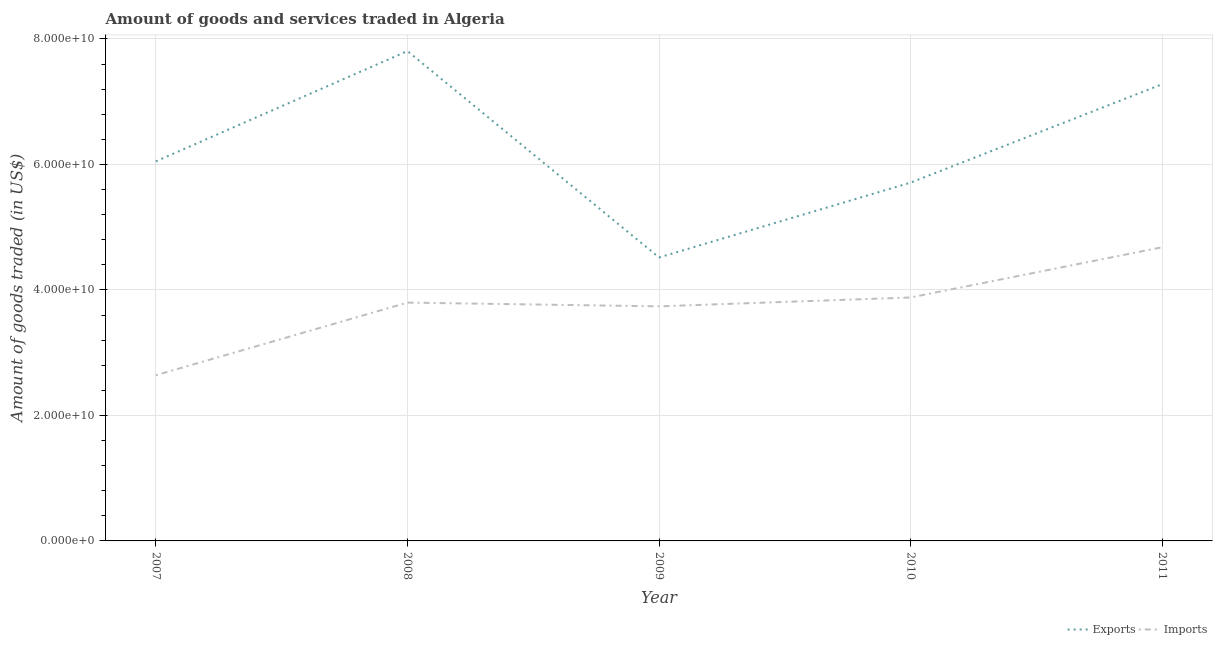What is the amount of goods exported in 2010?
Ensure brevity in your answer.  5.71e+1. Across all years, what is the maximum amount of goods exported?
Ensure brevity in your answer.  7.81e+1. Across all years, what is the minimum amount of goods exported?
Ensure brevity in your answer.  4.52e+1. In which year was the amount of goods exported minimum?
Your response must be concise. 2009. What is the total amount of goods exported in the graph?
Your answer should be very brief. 3.14e+11. What is the difference between the amount of goods imported in 2008 and that in 2011?
Make the answer very short. -8.82e+09. What is the difference between the amount of goods imported in 2008 and the amount of goods exported in 2009?
Provide a succinct answer. -7.19e+09. What is the average amount of goods imported per year?
Your response must be concise. 3.75e+1. In the year 2009, what is the difference between the amount of goods imported and amount of goods exported?
Provide a succinct answer. -7.79e+09. What is the ratio of the amount of goods imported in 2007 to that in 2011?
Give a very brief answer. 0.56. What is the difference between the highest and the second highest amount of goods imported?
Your answer should be compact. 8.00e+09. What is the difference between the highest and the lowest amount of goods exported?
Give a very brief answer. 3.29e+1. Does the amount of goods imported monotonically increase over the years?
Give a very brief answer. No. How many years are there in the graph?
Your answer should be very brief. 5. What is the difference between two consecutive major ticks on the Y-axis?
Provide a short and direct response. 2.00e+1. Are the values on the major ticks of Y-axis written in scientific E-notation?
Offer a very short reply. Yes. Does the graph contain any zero values?
Make the answer very short. No. Where does the legend appear in the graph?
Your answer should be very brief. Bottom right. What is the title of the graph?
Provide a short and direct response. Amount of goods and services traded in Algeria. What is the label or title of the X-axis?
Ensure brevity in your answer.  Year. What is the label or title of the Y-axis?
Make the answer very short. Amount of goods traded (in US$). What is the Amount of goods traded (in US$) of Exports in 2007?
Your answer should be very brief. 6.05e+1. What is the Amount of goods traded (in US$) in Imports in 2007?
Provide a short and direct response. 2.64e+1. What is the Amount of goods traded (in US$) of Exports in 2008?
Give a very brief answer. 7.81e+1. What is the Amount of goods traded (in US$) in Imports in 2008?
Offer a very short reply. 3.80e+1. What is the Amount of goods traded (in US$) in Exports in 2009?
Offer a terse response. 4.52e+1. What is the Amount of goods traded (in US$) of Imports in 2009?
Your response must be concise. 3.74e+1. What is the Amount of goods traded (in US$) of Exports in 2010?
Give a very brief answer. 5.71e+1. What is the Amount of goods traded (in US$) of Imports in 2010?
Provide a succinct answer. 3.88e+1. What is the Amount of goods traded (in US$) in Exports in 2011?
Offer a very short reply. 7.28e+1. What is the Amount of goods traded (in US$) of Imports in 2011?
Offer a terse response. 4.68e+1. Across all years, what is the maximum Amount of goods traded (in US$) of Exports?
Ensure brevity in your answer.  7.81e+1. Across all years, what is the maximum Amount of goods traded (in US$) in Imports?
Your answer should be compact. 4.68e+1. Across all years, what is the minimum Amount of goods traded (in US$) in Exports?
Ensure brevity in your answer.  4.52e+1. Across all years, what is the minimum Amount of goods traded (in US$) in Imports?
Give a very brief answer. 2.64e+1. What is the total Amount of goods traded (in US$) in Exports in the graph?
Offer a very short reply. 3.14e+11. What is the total Amount of goods traded (in US$) of Imports in the graph?
Give a very brief answer. 1.87e+11. What is the difference between the Amount of goods traded (in US$) of Exports in 2007 and that in 2008?
Give a very brief answer. -1.76e+1. What is the difference between the Amount of goods traded (in US$) in Imports in 2007 and that in 2008?
Offer a terse response. -1.16e+1. What is the difference between the Amount of goods traded (in US$) of Exports in 2007 and that in 2009?
Ensure brevity in your answer.  1.53e+1. What is the difference between the Amount of goods traded (in US$) in Imports in 2007 and that in 2009?
Your answer should be very brief. -1.10e+1. What is the difference between the Amount of goods traded (in US$) in Exports in 2007 and that in 2010?
Offer a terse response. 3.39e+09. What is the difference between the Amount of goods traded (in US$) of Imports in 2007 and that in 2010?
Give a very brief answer. -1.24e+1. What is the difference between the Amount of goods traded (in US$) in Exports in 2007 and that in 2011?
Keep it short and to the point. -1.23e+1. What is the difference between the Amount of goods traded (in US$) of Imports in 2007 and that in 2011?
Provide a short and direct response. -2.04e+1. What is the difference between the Amount of goods traded (in US$) of Exports in 2008 and that in 2009?
Make the answer very short. 3.29e+1. What is the difference between the Amount of goods traded (in US$) of Imports in 2008 and that in 2009?
Your answer should be very brief. 5.95e+08. What is the difference between the Amount of goods traded (in US$) of Exports in 2008 and that in 2010?
Give a very brief answer. 2.10e+1. What is the difference between the Amount of goods traded (in US$) in Imports in 2008 and that in 2010?
Provide a succinct answer. -8.17e+08. What is the difference between the Amount of goods traded (in US$) of Exports in 2008 and that in 2011?
Offer a very short reply. 5.28e+09. What is the difference between the Amount of goods traded (in US$) in Imports in 2008 and that in 2011?
Give a very brief answer. -8.82e+09. What is the difference between the Amount of goods traded (in US$) in Exports in 2009 and that in 2010?
Give a very brief answer. -1.19e+1. What is the difference between the Amount of goods traded (in US$) in Imports in 2009 and that in 2010?
Ensure brevity in your answer.  -1.41e+09. What is the difference between the Amount of goods traded (in US$) of Exports in 2009 and that in 2011?
Make the answer very short. -2.76e+1. What is the difference between the Amount of goods traded (in US$) in Imports in 2009 and that in 2011?
Give a very brief answer. -9.42e+09. What is the difference between the Amount of goods traded (in US$) of Exports in 2010 and that in 2011?
Offer a terse response. -1.57e+1. What is the difference between the Amount of goods traded (in US$) of Imports in 2010 and that in 2011?
Give a very brief answer. -8.00e+09. What is the difference between the Amount of goods traded (in US$) of Exports in 2007 and the Amount of goods traded (in US$) of Imports in 2008?
Offer a very short reply. 2.25e+1. What is the difference between the Amount of goods traded (in US$) of Exports in 2007 and the Amount of goods traded (in US$) of Imports in 2009?
Your answer should be very brief. 2.31e+1. What is the difference between the Amount of goods traded (in US$) of Exports in 2007 and the Amount of goods traded (in US$) of Imports in 2010?
Make the answer very short. 2.17e+1. What is the difference between the Amount of goods traded (in US$) in Exports in 2007 and the Amount of goods traded (in US$) in Imports in 2011?
Provide a succinct answer. 1.37e+1. What is the difference between the Amount of goods traded (in US$) of Exports in 2008 and the Amount of goods traded (in US$) of Imports in 2009?
Ensure brevity in your answer.  4.07e+1. What is the difference between the Amount of goods traded (in US$) in Exports in 2008 and the Amount of goods traded (in US$) in Imports in 2010?
Make the answer very short. 3.93e+1. What is the difference between the Amount of goods traded (in US$) of Exports in 2008 and the Amount of goods traded (in US$) of Imports in 2011?
Offer a terse response. 3.13e+1. What is the difference between the Amount of goods traded (in US$) of Exports in 2009 and the Amount of goods traded (in US$) of Imports in 2010?
Ensure brevity in your answer.  6.38e+09. What is the difference between the Amount of goods traded (in US$) of Exports in 2009 and the Amount of goods traded (in US$) of Imports in 2011?
Provide a short and direct response. -1.63e+09. What is the difference between the Amount of goods traded (in US$) in Exports in 2010 and the Amount of goods traded (in US$) in Imports in 2011?
Your response must be concise. 1.03e+1. What is the average Amount of goods traded (in US$) in Exports per year?
Your response must be concise. 6.27e+1. What is the average Amount of goods traded (in US$) in Imports per year?
Ensure brevity in your answer.  3.75e+1. In the year 2007, what is the difference between the Amount of goods traded (in US$) in Exports and Amount of goods traded (in US$) in Imports?
Your answer should be very brief. 3.41e+1. In the year 2008, what is the difference between the Amount of goods traded (in US$) of Exports and Amount of goods traded (in US$) of Imports?
Offer a terse response. 4.01e+1. In the year 2009, what is the difference between the Amount of goods traded (in US$) of Exports and Amount of goods traded (in US$) of Imports?
Your answer should be very brief. 7.79e+09. In the year 2010, what is the difference between the Amount of goods traded (in US$) in Exports and Amount of goods traded (in US$) in Imports?
Offer a terse response. 1.83e+1. In the year 2011, what is the difference between the Amount of goods traded (in US$) in Exports and Amount of goods traded (in US$) in Imports?
Your response must be concise. 2.60e+1. What is the ratio of the Amount of goods traded (in US$) in Exports in 2007 to that in 2008?
Your answer should be very brief. 0.77. What is the ratio of the Amount of goods traded (in US$) of Imports in 2007 to that in 2008?
Ensure brevity in your answer.  0.7. What is the ratio of the Amount of goods traded (in US$) of Exports in 2007 to that in 2009?
Your response must be concise. 1.34. What is the ratio of the Amount of goods traded (in US$) in Imports in 2007 to that in 2009?
Offer a very short reply. 0.71. What is the ratio of the Amount of goods traded (in US$) of Exports in 2007 to that in 2010?
Make the answer very short. 1.06. What is the ratio of the Amount of goods traded (in US$) of Imports in 2007 to that in 2010?
Make the answer very short. 0.68. What is the ratio of the Amount of goods traded (in US$) in Exports in 2007 to that in 2011?
Give a very brief answer. 0.83. What is the ratio of the Amount of goods traded (in US$) of Imports in 2007 to that in 2011?
Your answer should be very brief. 0.56. What is the ratio of the Amount of goods traded (in US$) in Exports in 2008 to that in 2009?
Your answer should be very brief. 1.73. What is the ratio of the Amount of goods traded (in US$) in Imports in 2008 to that in 2009?
Offer a terse response. 1.02. What is the ratio of the Amount of goods traded (in US$) of Exports in 2008 to that in 2010?
Your answer should be very brief. 1.37. What is the ratio of the Amount of goods traded (in US$) of Imports in 2008 to that in 2010?
Provide a succinct answer. 0.98. What is the ratio of the Amount of goods traded (in US$) in Exports in 2008 to that in 2011?
Your answer should be compact. 1.07. What is the ratio of the Amount of goods traded (in US$) of Imports in 2008 to that in 2011?
Give a very brief answer. 0.81. What is the ratio of the Amount of goods traded (in US$) of Exports in 2009 to that in 2010?
Offer a very short reply. 0.79. What is the ratio of the Amount of goods traded (in US$) of Imports in 2009 to that in 2010?
Keep it short and to the point. 0.96. What is the ratio of the Amount of goods traded (in US$) in Exports in 2009 to that in 2011?
Your answer should be compact. 0.62. What is the ratio of the Amount of goods traded (in US$) in Imports in 2009 to that in 2011?
Provide a succinct answer. 0.8. What is the ratio of the Amount of goods traded (in US$) of Exports in 2010 to that in 2011?
Your answer should be very brief. 0.78. What is the ratio of the Amount of goods traded (in US$) in Imports in 2010 to that in 2011?
Ensure brevity in your answer.  0.83. What is the difference between the highest and the second highest Amount of goods traded (in US$) in Exports?
Offer a very short reply. 5.28e+09. What is the difference between the highest and the second highest Amount of goods traded (in US$) of Imports?
Offer a very short reply. 8.00e+09. What is the difference between the highest and the lowest Amount of goods traded (in US$) of Exports?
Your answer should be very brief. 3.29e+1. What is the difference between the highest and the lowest Amount of goods traded (in US$) of Imports?
Ensure brevity in your answer.  2.04e+1. 